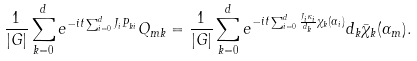Convert formula to latex. <formula><loc_0><loc_0><loc_500><loc_500>\frac { 1 } { | G | } \sum _ { k = 0 } ^ { d } e ^ { - i t \sum _ { i = 0 } ^ { d } J _ { i } P _ { k i } } Q _ { m k } = \frac { 1 } { | G | } \sum _ { k = 0 } ^ { d } e ^ { - i t \sum _ { i = 0 } ^ { d } \frac { J _ { i } \kappa _ { i } } { d _ { k } } \chi _ { k } ( \alpha _ { i } ) } d _ { k } \bar { \chi } _ { k } ( \alpha _ { m } ) .</formula> 